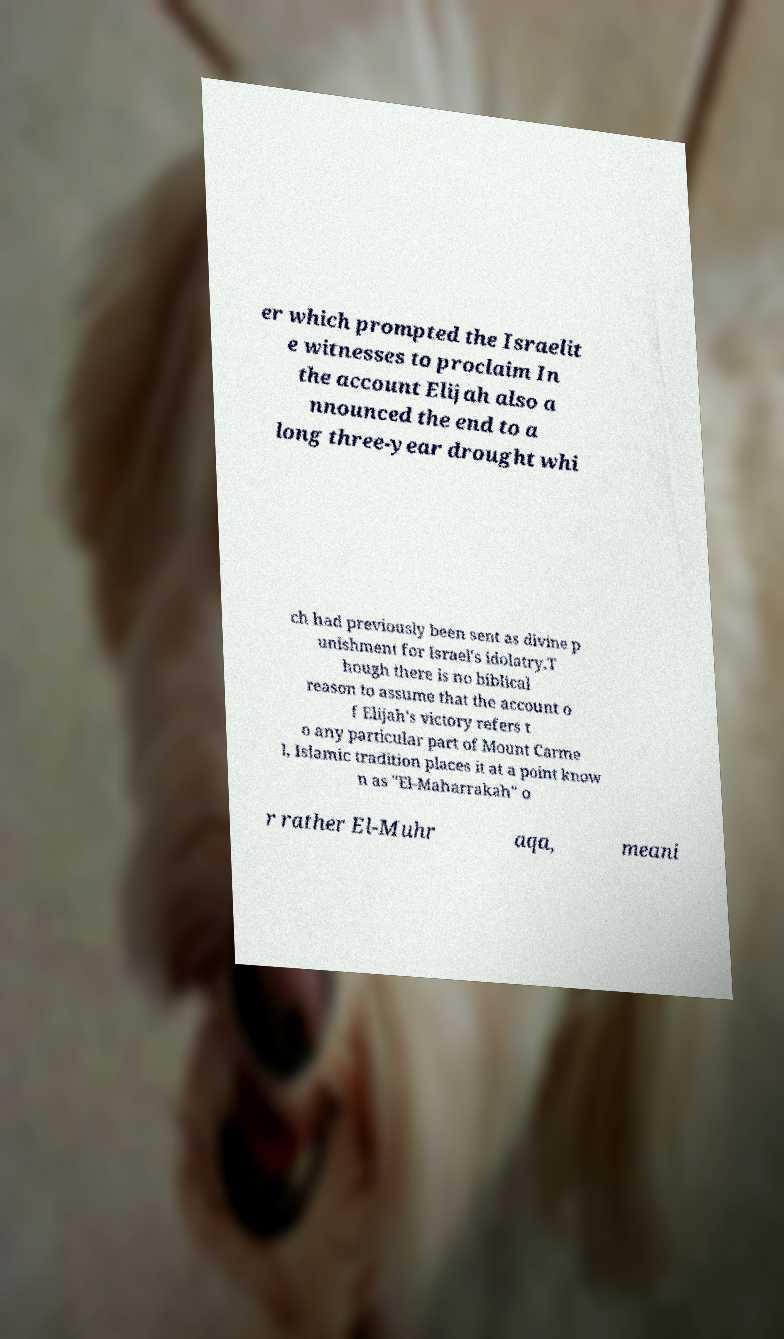Please read and relay the text visible in this image. What does it say? er which prompted the Israelit e witnesses to proclaim In the account Elijah also a nnounced the end to a long three-year drought whi ch had previously been sent as divine p unishment for Israel's idolatry.T hough there is no biblical reason to assume that the account o f Elijah's victory refers t o any particular part of Mount Carme l, Islamic tradition places it at a point know n as "El-Maharrakah" o r rather El-Muhr aqa, meani 